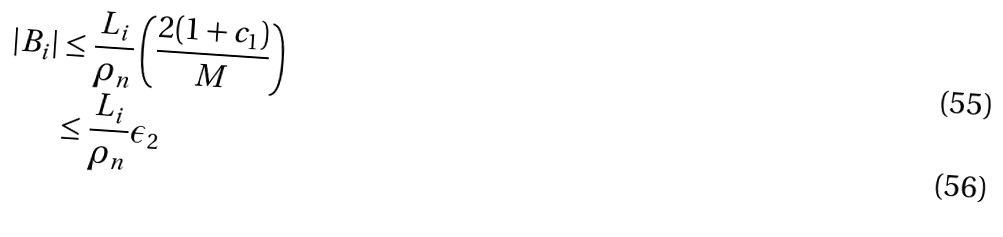<formula> <loc_0><loc_0><loc_500><loc_500>| B _ { i } | & \leq \frac { L _ { i } } { \rho _ { n } } \left ( \frac { 2 ( 1 + c _ { 1 } ) } { M } \right ) \\ & \leq \frac { L _ { i } } { \rho _ { n } } \epsilon _ { 2 }</formula> 